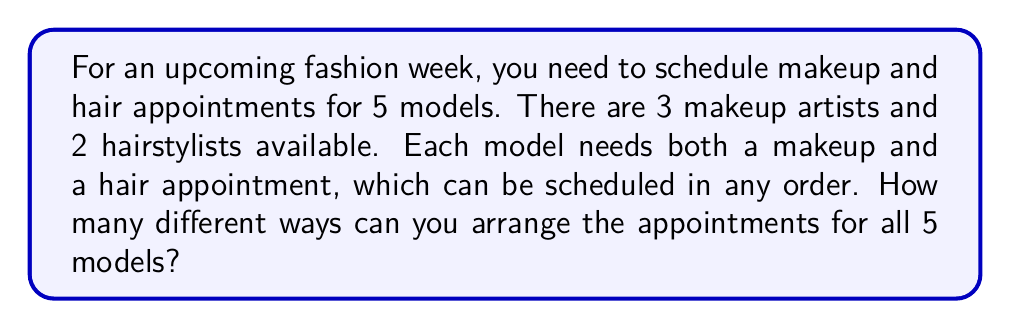Can you answer this question? Let's break this down step-by-step:

1) For each model, we need to make two decisions:
   a) Which makeup artist to choose (3 options)
   b) Which hairstylist to choose (2 options)

2) The order of makeup and hair doesn't matter for each individual model, so we don't need to consider that.

3) For a single model, the number of possible combinations is:
   $3 \times 2 = 6$

4) Now, we need to make this choice for all 5 models independently. This is a case of the multiplication principle.

5) The total number of ways to arrange appointments for all 5 models is:
   $6^5 = 6 \times 6 \times 6 \times 6 \times 6$

6) Let's calculate this:
   $6^5 = 7,776$

Therefore, there are 7,776 different ways to schedule the appointments for all 5 models.
Answer: 7,776 